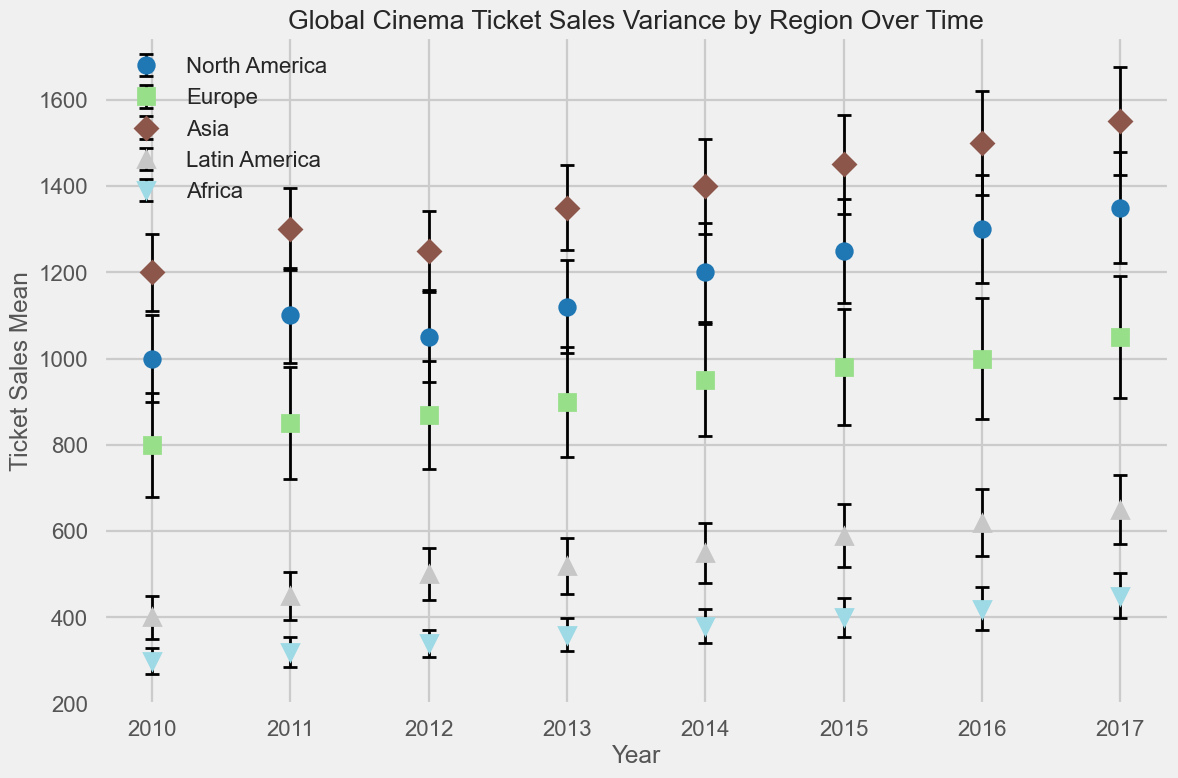Which region has the highest cinema ticket sales mean in 2017? Look at the year 2017 and compare the ticket sales means for all regions. Asia has the highest mean at 1550.
Answer: Asia What is the difference in ticket sales mean between North America and Europe in 2015? Refer to the year 2015, find the ticket sales means for North America (1250) and Europe (980), and calculate the difference: 1250 - 980 = 270.
Answer: 270 Which region shows the lowest ticket sales mean in 2010? Look at the year 2010 and compare the ticket sales means for all regions. Africa has the lowest mean at 300.
Answer: Africa Between 2016 and 2017, which region has the largest increase in ticket sales mean? Compare the ticket sales means for each region between 2016 and 2017. Europe shows the largest increase from 1000 to 1050, which is a 50 unit increase.
Answer: Europe What is the average ticket sales mean for Asia from 2010 to 2017? Sum up the ticket sales means for Asia from 2010 to 2017 (1200 + 1300 + 1250 + 1350 + 1400 + 1450 + 1500 + 1550) and divide by 8 (number of years): (1200 + 1300 + 1250 + 1350 + 1400 + 1450 + 1500 + 1550)/8 = 1375.
Answer: 1375 Which region has the largest error bar (standard deviation) in 2014? Look at the error bars (standard deviations) for each region in 2014. Europe has the largest standard deviation at 130.
Answer: Europe What is the combined ticket sales mean for Latin America over the years 2013 and 2014? Find the ticket sales means for Latin America in 2013 (520) and 2014 (550), then sum them: 520 + 550 = 1070.
Answer: 1070 Which region has a steadily increasing trend in ticket sales mean from 2010 to 2017? Examine the trend lines for each region from 2010 to 2017. North America has a steadily increasing trend from 1000 to 1350.
Answer: North America What is the difference in ticket sales mean between the maximum and minimum regions in 2012? In 2012, find the maximum (Asia, 1250) and minimum (Africa, 340) ticket sales means and calculate the difference: 1250 - 340 = 910.
Answer: 910 By how much did the ticket sales mean for Africa change from 2010 to 2017? Compare the ticket sales mean for Africa in 2010 (300) and 2017 (450) and calculate the difference: 450 - 300 = 150.
Answer: 150 